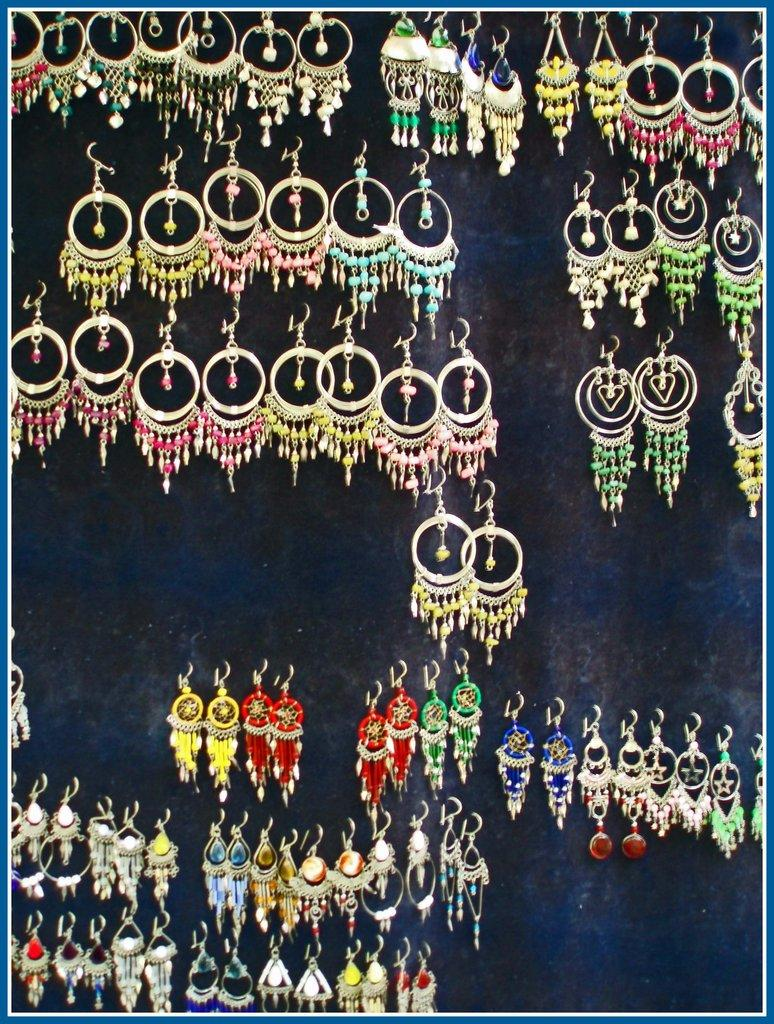What type of accessory is featured in the image? There are colorful earrings in the image. Where are the earrings placed in the image? The earrings are hanging on a blue board. Can you hear the geese singing while driving in the image? There are no geese or driving depicted in the image, and therefore no such activity or sound can be observed. 